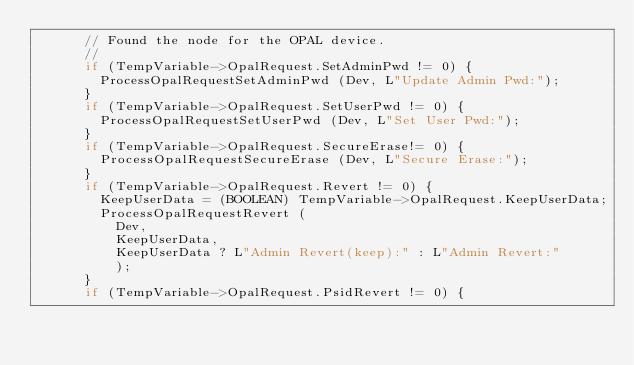<code> <loc_0><loc_0><loc_500><loc_500><_C_>      // Found the node for the OPAL device.
      //
      if (TempVariable->OpalRequest.SetAdminPwd != 0) {
        ProcessOpalRequestSetAdminPwd (Dev, L"Update Admin Pwd:");
      }
      if (TempVariable->OpalRequest.SetUserPwd != 0) {
        ProcessOpalRequestSetUserPwd (Dev, L"Set User Pwd:");
      }
      if (TempVariable->OpalRequest.SecureErase!= 0) {
        ProcessOpalRequestSecureErase (Dev, L"Secure Erase:");
      }
      if (TempVariable->OpalRequest.Revert != 0) {
        KeepUserData = (BOOLEAN) TempVariable->OpalRequest.KeepUserData;
        ProcessOpalRequestRevert (
          Dev,
          KeepUserData,
          KeepUserData ? L"Admin Revert(keep):" : L"Admin Revert:"
          );
      }
      if (TempVariable->OpalRequest.PsidRevert != 0) {</code> 